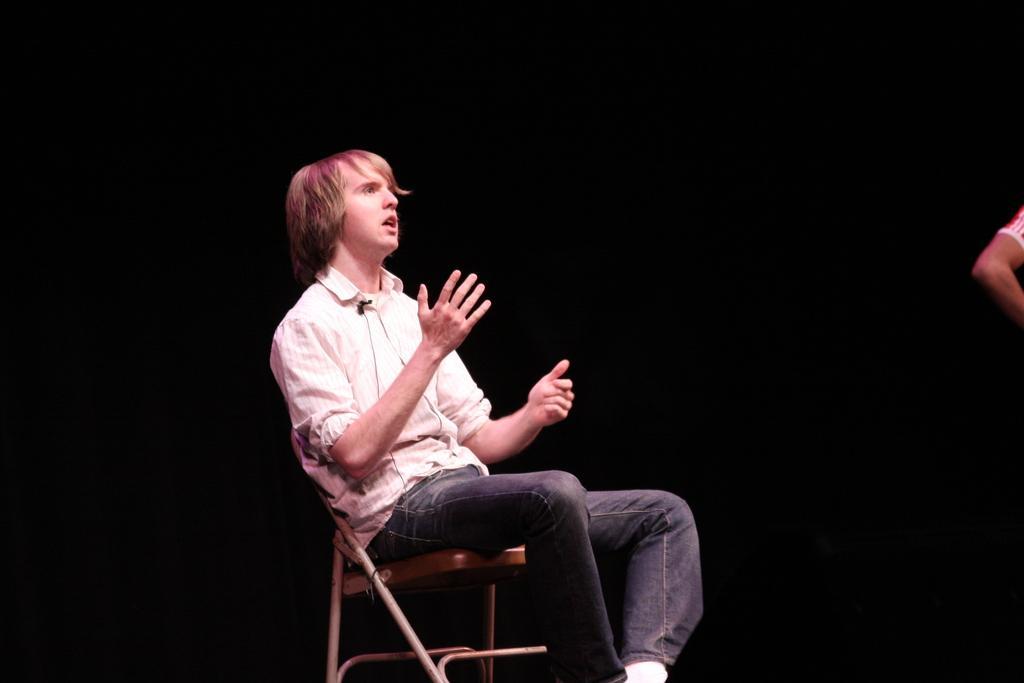Please provide a concise description of this image. In the picture there is a man sitting on the chair, beside the man there is a hand of a person present. 